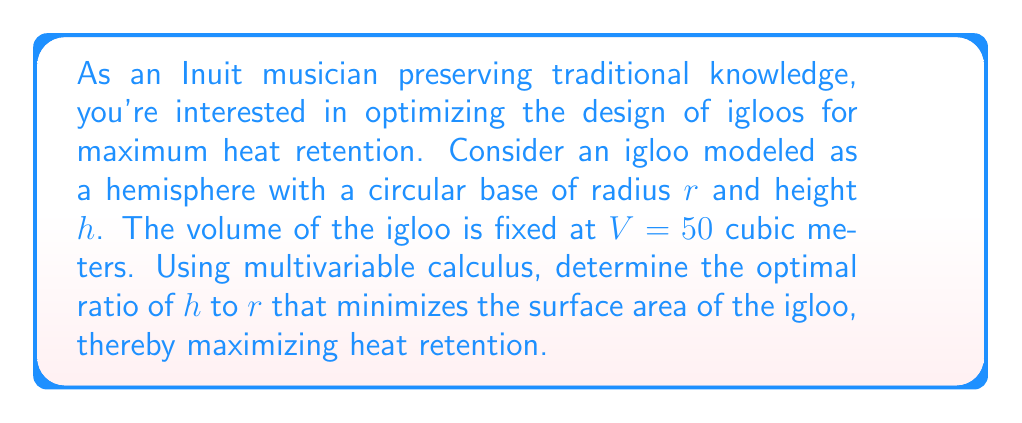Give your solution to this math problem. Let's approach this problem step-by-step using multivariable calculus:

1) First, we need to express the volume and surface area of the hemisphere in terms of $r$ and $h$:

   Volume: $V = \frac{2}{3}\pi r^2 h$
   Surface Area: $SA = \pi r^2 + 2\pi r h$

2) We're given that the volume is fixed at 50 cubic meters:

   $50 = \frac{2}{3}\pi r^2 h$

3) We can express $h$ in terms of $r$:

   $h = \frac{75}{\pi r^2}$

4) Now, let's substitute this into the surface area equation:

   $SA = \pi r^2 + 2\pi r (\frac{75}{\pi r^2}) = \pi r^2 + \frac{150}{r}$

5) To minimize the surface area, we need to find where its derivative with respect to $r$ is zero:

   $\frac{dSA}{dr} = 2\pi r - \frac{150}{r^2} = 0$

6) Solving this equation:

   $2\pi r^3 = 150$
   $r^3 = \frac{75}{\pi}$
   $r = \sqrt[3]{\frac{75}{\pi}}$

7) Now we can find $h$:

   $h = \frac{75}{\pi r^2} = \frac{75}{\pi (\sqrt[3]{\frac{75}{\pi}})^2} = \sqrt[3]{\frac{75}{\pi}}$

8) The optimal ratio of $h$ to $r$ is therefore 1:1.

To verify this is a minimum, we can check the second derivative is positive at this point.
Answer: The optimal ratio of height to radius for maximum heat retention is $h:r = 1:1$. Both $h$ and $r$ should equal $\sqrt[3]{\frac{75}{\pi}} \approx 2.88$ meters. 